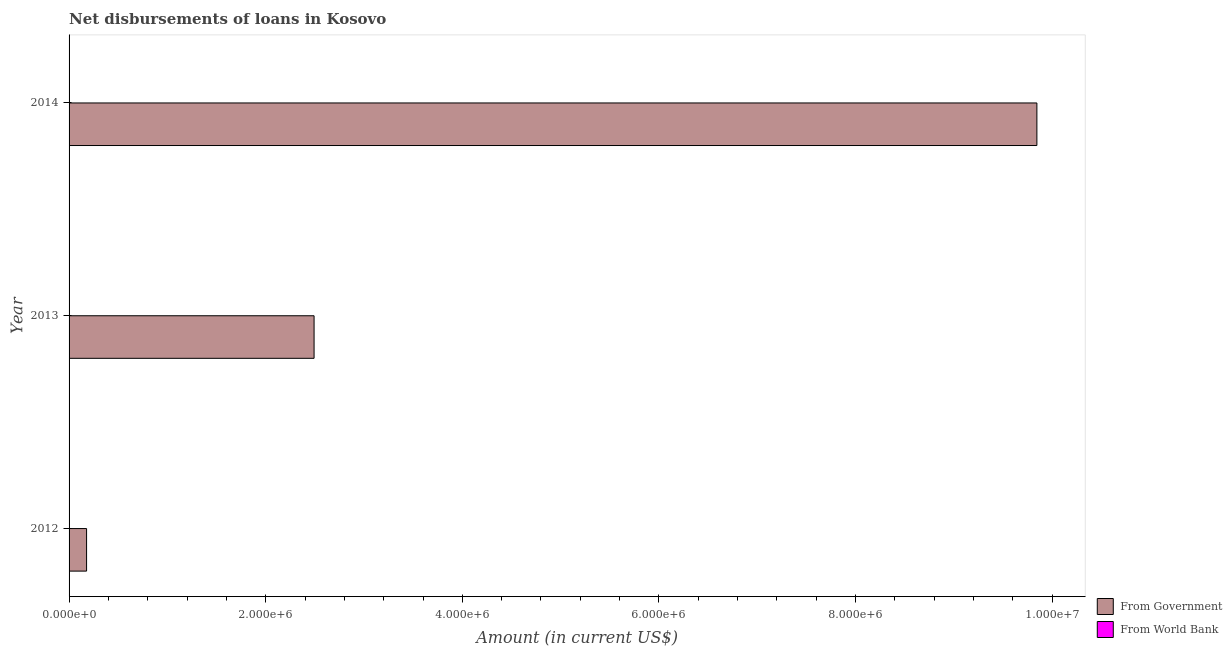How many different coloured bars are there?
Your response must be concise. 1. Are the number of bars per tick equal to the number of legend labels?
Ensure brevity in your answer.  No. How many bars are there on the 3rd tick from the top?
Give a very brief answer. 1. How many bars are there on the 3rd tick from the bottom?
Your response must be concise. 1. What is the net disbursements of loan from government in 2013?
Give a very brief answer. 2.49e+06. Across all years, what is the maximum net disbursements of loan from government?
Provide a short and direct response. 9.84e+06. What is the difference between the net disbursements of loan from government in 2013 and that in 2014?
Keep it short and to the point. -7.35e+06. What is the difference between the net disbursements of loan from government in 2012 and the net disbursements of loan from world bank in 2013?
Keep it short and to the point. 1.78e+05. What is the average net disbursements of loan from government per year?
Keep it short and to the point. 4.17e+06. In how many years, is the net disbursements of loan from government greater than 4800000 US$?
Keep it short and to the point. 1. What is the ratio of the net disbursements of loan from government in 2013 to that in 2014?
Your answer should be very brief. 0.25. Is the net disbursements of loan from government in 2012 less than that in 2013?
Your answer should be very brief. Yes. What is the difference between the highest and the second highest net disbursements of loan from government?
Offer a terse response. 7.35e+06. What is the difference between the highest and the lowest net disbursements of loan from government?
Offer a terse response. 9.67e+06. In how many years, is the net disbursements of loan from government greater than the average net disbursements of loan from government taken over all years?
Provide a succinct answer. 1. Is the sum of the net disbursements of loan from government in 2012 and 2014 greater than the maximum net disbursements of loan from world bank across all years?
Your response must be concise. Yes. How many bars are there?
Make the answer very short. 3. Are all the bars in the graph horizontal?
Give a very brief answer. Yes. Does the graph contain grids?
Keep it short and to the point. No. Where does the legend appear in the graph?
Your answer should be very brief. Bottom right. How many legend labels are there?
Your answer should be compact. 2. What is the title of the graph?
Keep it short and to the point. Net disbursements of loans in Kosovo. Does "Imports" appear as one of the legend labels in the graph?
Offer a very short reply. No. What is the Amount (in current US$) in From Government in 2012?
Provide a succinct answer. 1.78e+05. What is the Amount (in current US$) in From World Bank in 2012?
Provide a short and direct response. 0. What is the Amount (in current US$) in From Government in 2013?
Your answer should be compact. 2.49e+06. What is the Amount (in current US$) in From Government in 2014?
Your response must be concise. 9.84e+06. What is the Amount (in current US$) of From World Bank in 2014?
Ensure brevity in your answer.  0. Across all years, what is the maximum Amount (in current US$) of From Government?
Provide a short and direct response. 9.84e+06. Across all years, what is the minimum Amount (in current US$) in From Government?
Provide a succinct answer. 1.78e+05. What is the total Amount (in current US$) in From Government in the graph?
Offer a very short reply. 1.25e+07. What is the total Amount (in current US$) in From World Bank in the graph?
Offer a terse response. 0. What is the difference between the Amount (in current US$) of From Government in 2012 and that in 2013?
Make the answer very short. -2.31e+06. What is the difference between the Amount (in current US$) of From Government in 2012 and that in 2014?
Your answer should be compact. -9.67e+06. What is the difference between the Amount (in current US$) in From Government in 2013 and that in 2014?
Offer a terse response. -7.35e+06. What is the average Amount (in current US$) of From Government per year?
Ensure brevity in your answer.  4.17e+06. What is the ratio of the Amount (in current US$) in From Government in 2012 to that in 2013?
Your answer should be very brief. 0.07. What is the ratio of the Amount (in current US$) in From Government in 2012 to that in 2014?
Offer a terse response. 0.02. What is the ratio of the Amount (in current US$) of From Government in 2013 to that in 2014?
Your answer should be compact. 0.25. What is the difference between the highest and the second highest Amount (in current US$) of From Government?
Make the answer very short. 7.35e+06. What is the difference between the highest and the lowest Amount (in current US$) of From Government?
Keep it short and to the point. 9.67e+06. 